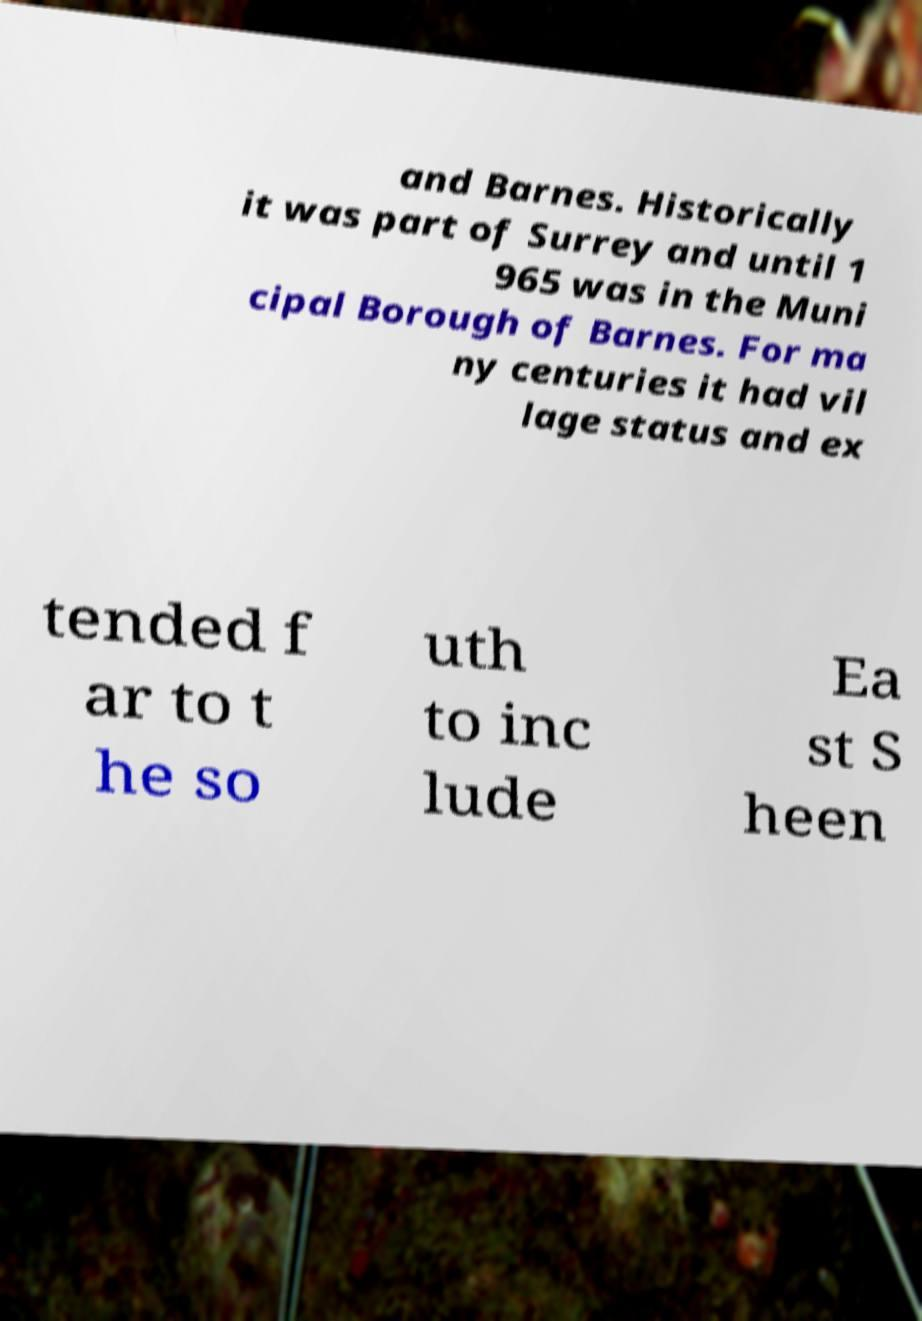I need the written content from this picture converted into text. Can you do that? and Barnes. Historically it was part of Surrey and until 1 965 was in the Muni cipal Borough of Barnes. For ma ny centuries it had vil lage status and ex tended f ar to t he so uth to inc lude Ea st S heen 